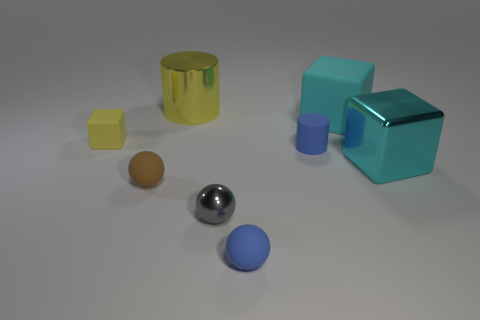How many cyan cubes must be subtracted to get 1 cyan cubes? 1 Add 2 small gray shiny balls. How many objects exist? 10 Subtract all cylinders. How many objects are left? 6 Subtract 1 blue cylinders. How many objects are left? 7 Subtract all metallic cylinders. Subtract all small blue objects. How many objects are left? 5 Add 2 large yellow shiny cylinders. How many large yellow shiny cylinders are left? 3 Add 2 matte cylinders. How many matte cylinders exist? 3 